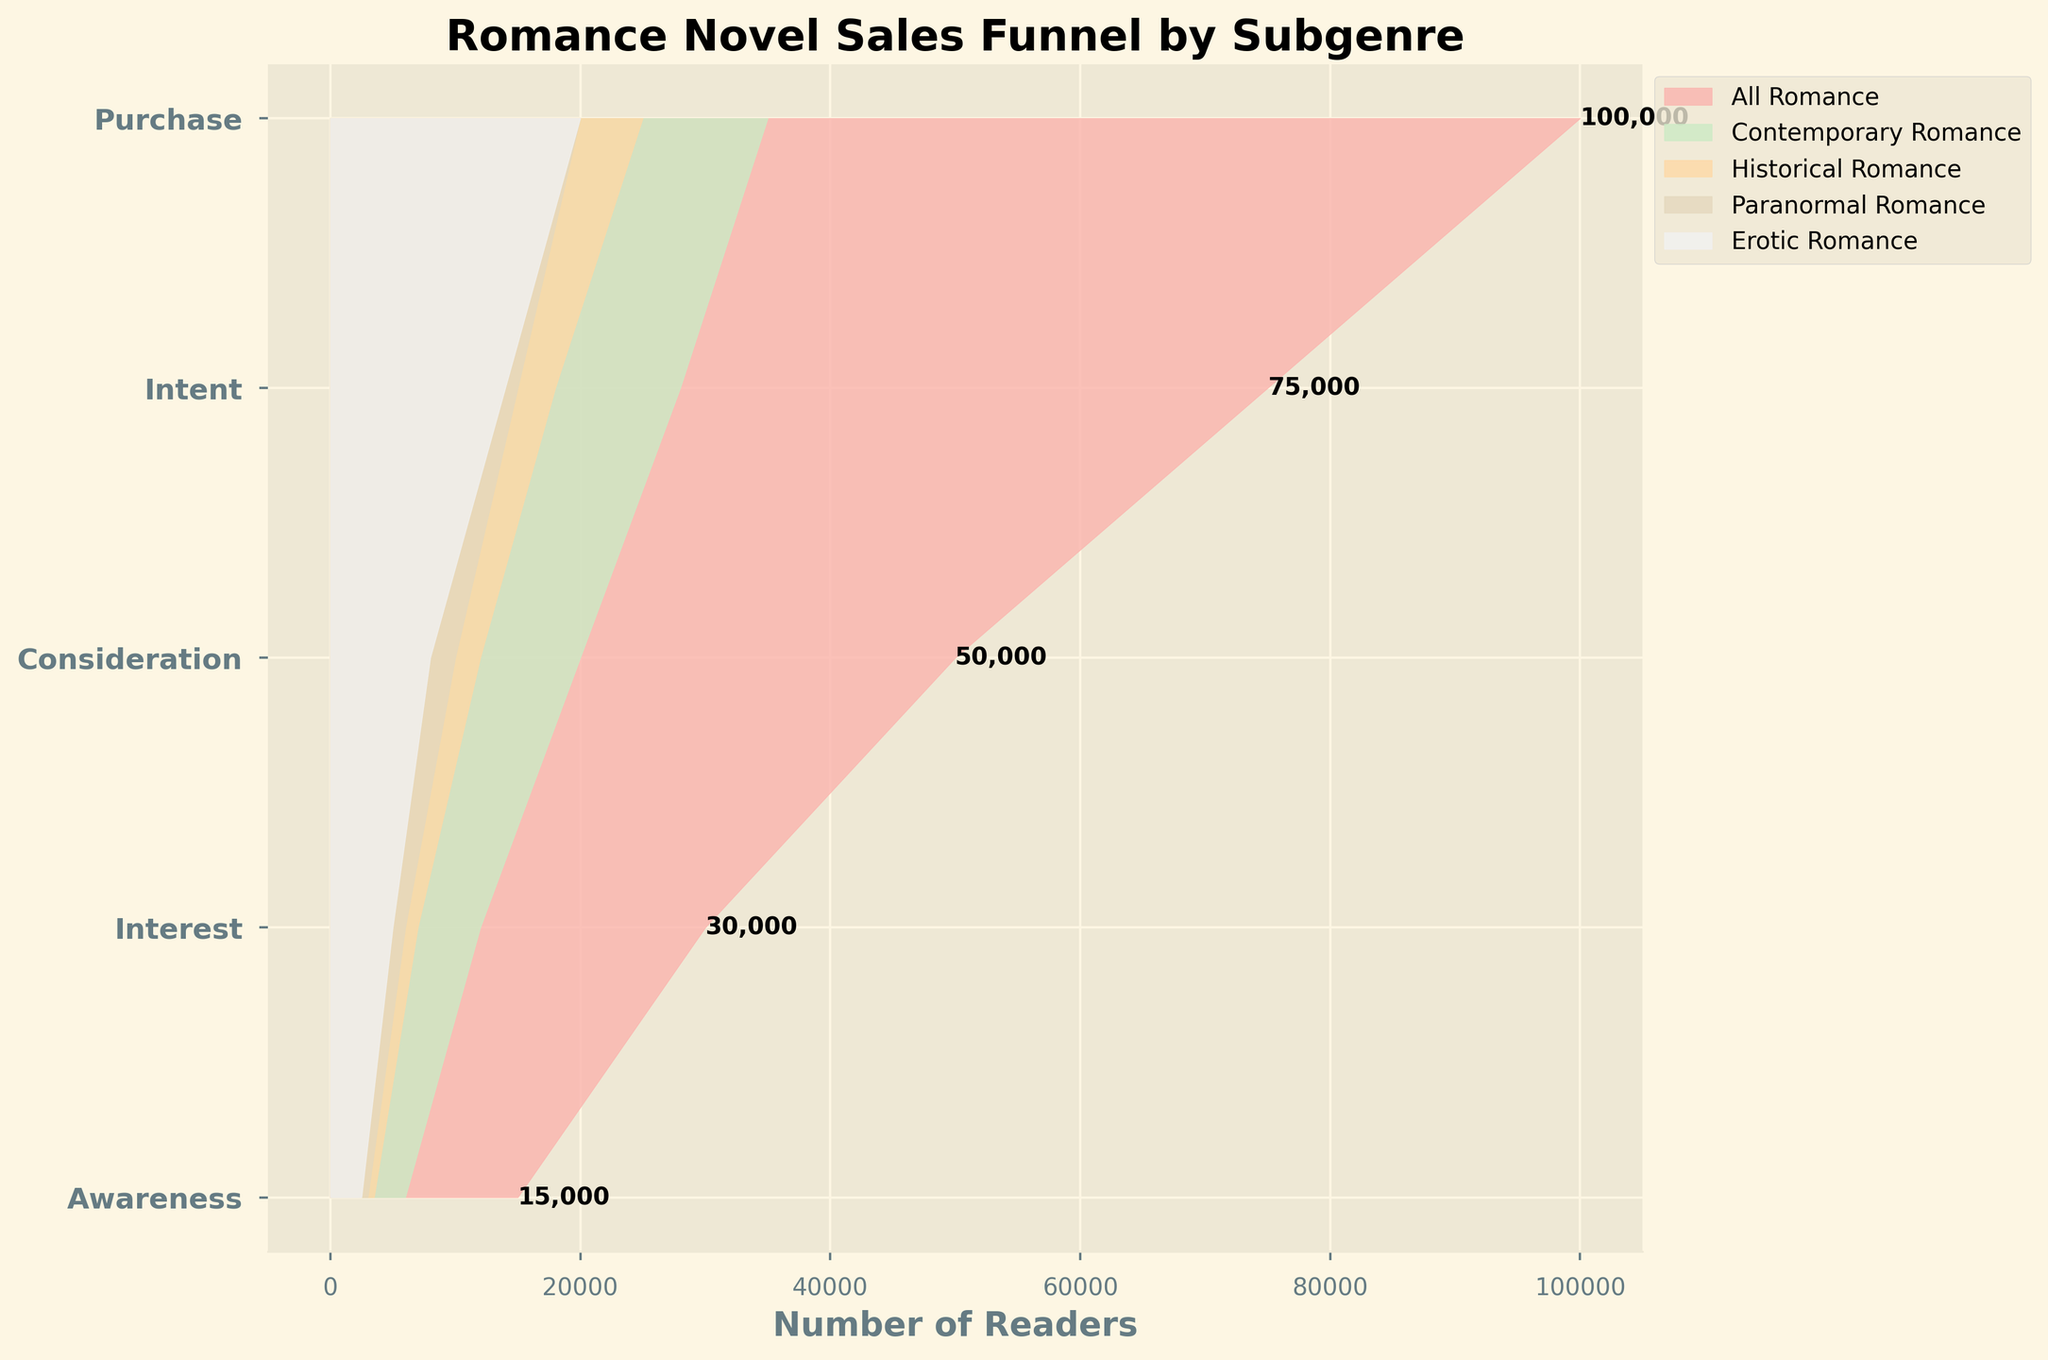what is the title of the funnel chart? The title of the chart is displayed at the top of the funnel, indicating the main topic it represents. In this case, the title is "Romance Novel Sales Funnel by Subgenre."
Answer: "Romance Novel Sales Funnel by Subgenre" What does the x-axis represent in the figure? The x-axis is labeled as 'Number of Readers,' which shows the number of readers at each stage of the sales funnel, corresponding to the different subgenres.
Answer: Number of Readers Which subgenre has the largest number of readers in the 'Interest' stage? By looking at the 'Interest' stage in the funnel chart, the height of the sections can be compared. The Contemporary Romance subgenre extends the furthest to the right, indicating it has the most readers in this stage.
Answer: Contemporary Romance What is the difference in the number of readers between 'Awareness' and 'Purchase' stages for 'Paranormal Romance'? To find this difference, subtract the number of readers at the 'Purchase' stage from those at the 'Awareness' stage for Paranormal Romance. The numbers are 20000 (Awareness) and 3000 (Purchase), so: 20000 - 3000 = 17000
Answer: 17000 How many total readers are interested in 'Historical Romance' at the 'Consideration' stage? At the 'Consideration' stage, directly refer to the value for Historical Romance. It is 12000.
Answer: 12000 Which subgenre has the smallest decrease in the number of readers from 'Consideration' to 'Intent' stages? To find this, calculate the difference between the 'Consideration' and 'Intent' stages for each subgenre and compare them. Historic Romance: 12000 - 7000 = 5000; Contemporary Romance: 20000 - 12000 = 8000; Paranormal Romance: 10000 - 6000 = 4000; Erotic Romance: 8000 - 5000 = 3000. The smallest difference is for 'Erotic Romance'.
Answer: Erotic Romance What is the sum of readers in 'Awareness' across all subgenres? Add the number of readers in the 'Awareness' stage for all subgenres: 35000 (Contemporary) + 25000 (Historical) + 20000 (Paranormal) + 20000 (Erotic) = 100000
Answer: 100000 Which subgenre shows the highest retention rate from 'Interest' to 'Consideration'? To calculate this, for each subgenre, divide the number of 'Consideration' readers by the number of 'Interest' readers and find the highest. Contemporary: 20000/28000 ≈ 0.71; Historical: 12000/18000 ≈ 0.67; Paranormal: 10000/15000 ≈ 0.67; Erotic: 8000/14000 ≈ 0.57. The highest retention rate is for Contemporary Romance, about 0.71
Answer: Contemporary Romance What is the total number of readers who made a 'Purchase' for 'Erotic Romance'? Directly refer to the 'Purchase' stage value for Erotic Romance, which is given as 2500 readers.
Answer: 2500 